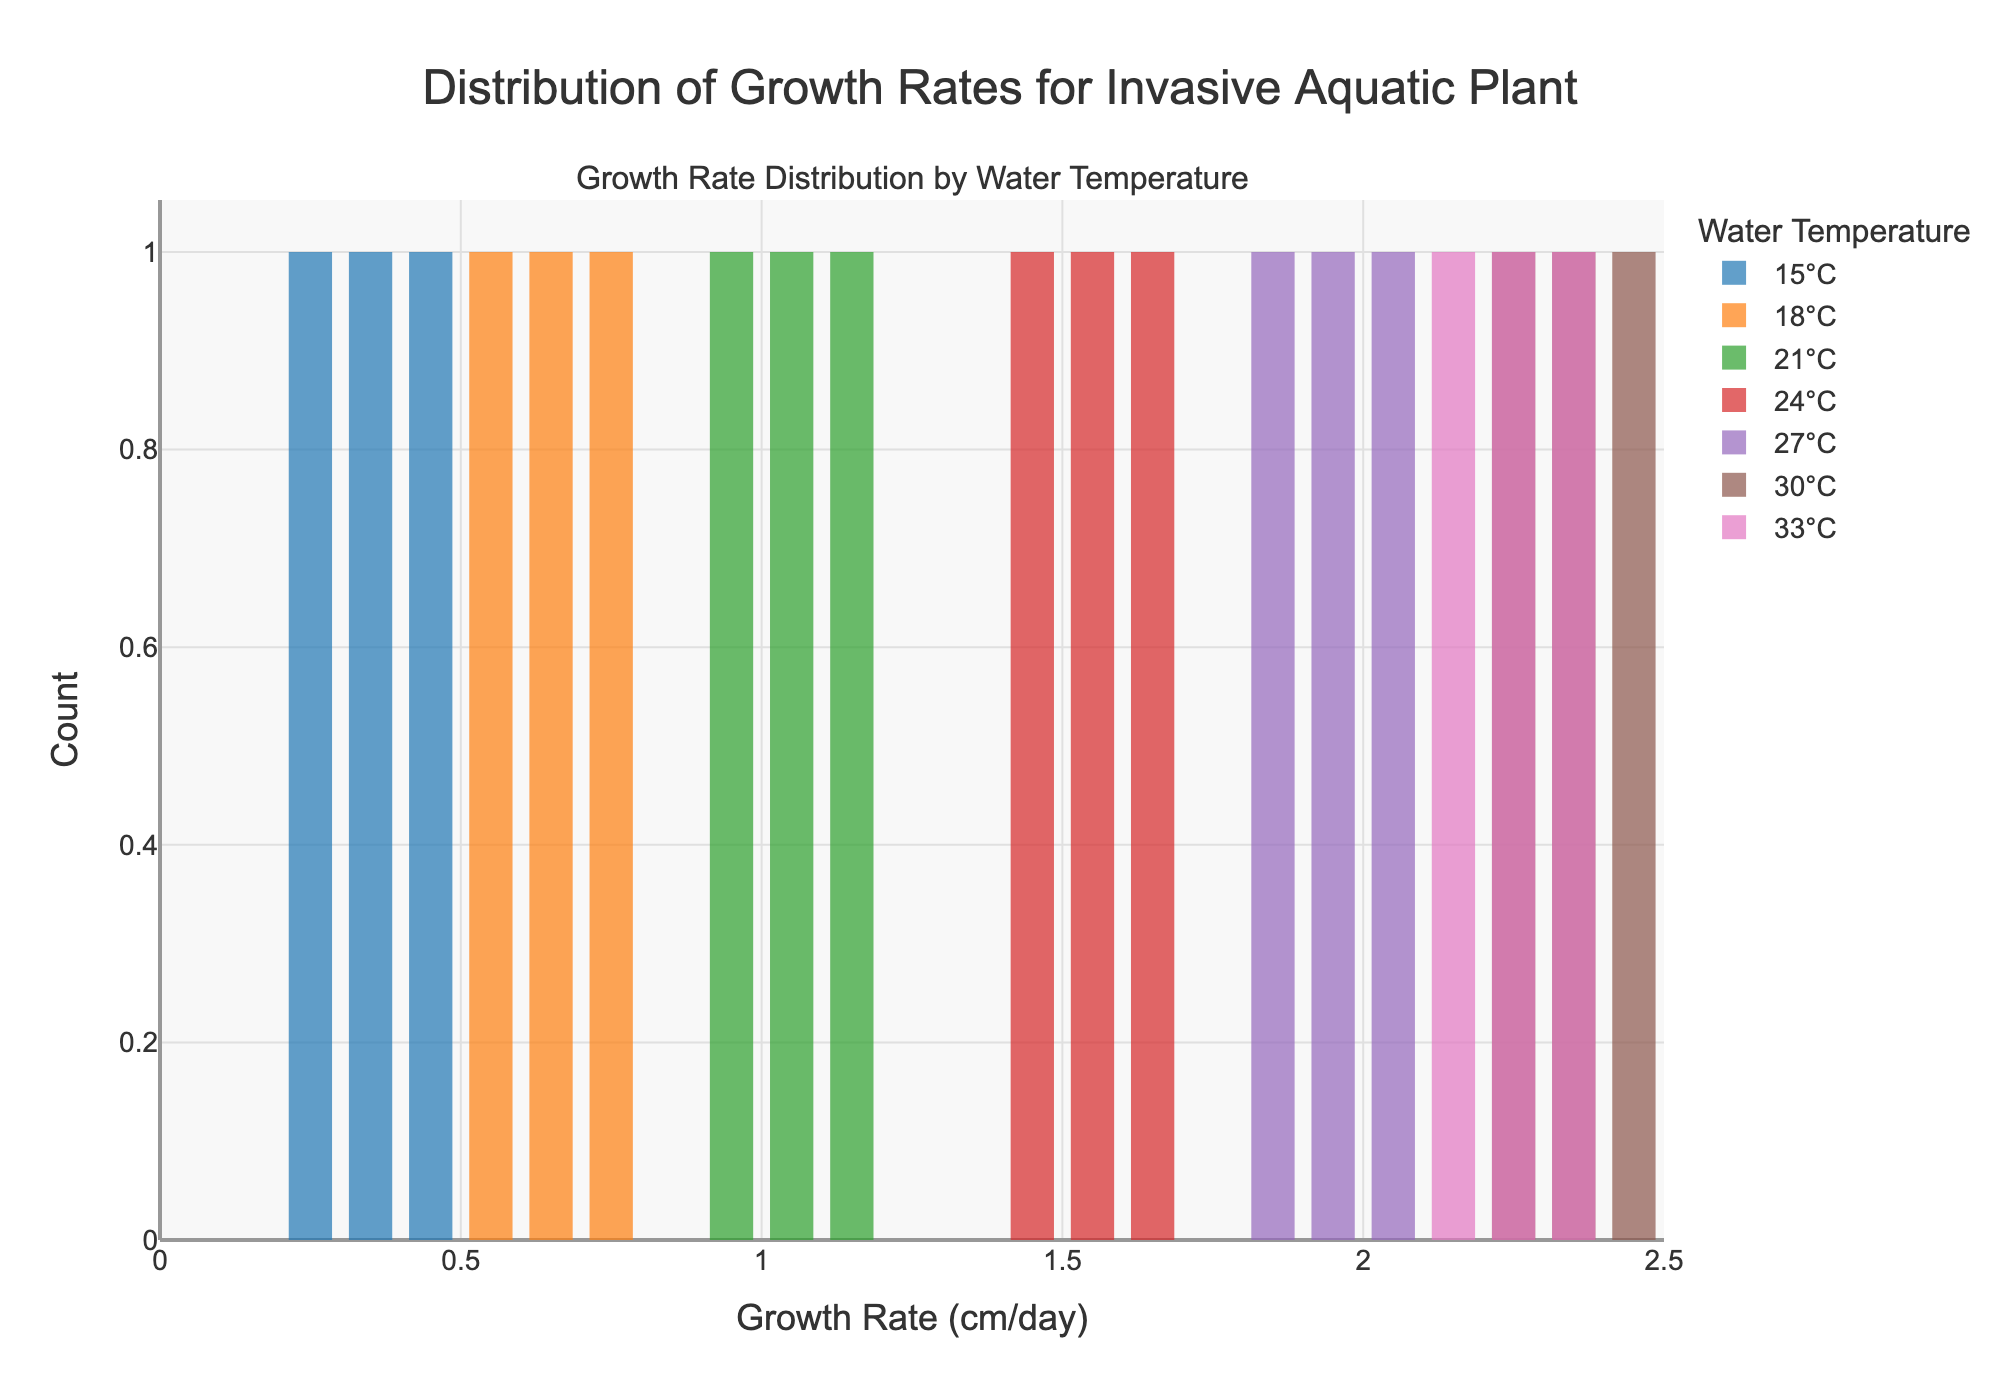How many different water temperatures are represented in the figure? The figure shows histograms for each water temperature. By counting the unique labels in the legend, we see there are seven different water temperatures.
Answer: 7 Which water temperature has the highest growth rate observed? By inspecting the histograms, the highest bar appears in the 30°C category, with growth rates reaching up to 2.4 cm/day.
Answer: 30°C What is the range of growth rates for the water temperature of 21°C? The histogram bars for 21°C span from 0.9 to 1.1 cm/day, so the range is 1.1 - 0.9.
Answer: 0.2 cm/day Which water temperature has the widest range of growth rates? We need to compare the spans of the histograms. The histogram for 33°C shows growth rates from about 2.1 to 2.3 cm/day, a range of 0.2. By comparing this with other histograms, it appears that 15°C has a range from 0.2 to 0.4 (0.2), and 30°C ranges from 2.2 to 2.4 (0.2). The histogram with the widest span, from 1.8 to 2.0 (0.2), is 27°C.
Answer: 27°C At which water temperature do we see the most uniform distribution of growth rates across the bins? The most uniform distribution would have roughly the same height for each bin within a temperature category. The 15°C histogram appears to show a relatively uniform distribution with bars of nearly equal height (around 0.2 to 0.4 cm/day).
Answer: 15°C For water temperatures between 24°C and 27°C, what is the maximum observed growth rate? Examining histograms within the temperatures 24°C and 27°C, the highest bar is at 27°C matching the 2.0 cm/day mark.
Answer: 2.0 cm/day Which water temperature has the highest count in a single growth rate bin? By referring to the histograms, the largest count within a single bin appears under the 30°C histogram, where the bin spanning 2.3 to 2.4 has the highest count.
Answer: 30°C What is the median growth rate for the water temperature of 18°C? The median is the middle value when numbers are sorted. For 18°C, the growth rates are 0.5, 0.6, and 0.7 cm/day. Hence, the median is the middle value 0.6 cm/day.
Answer: 0.6 cm/day 